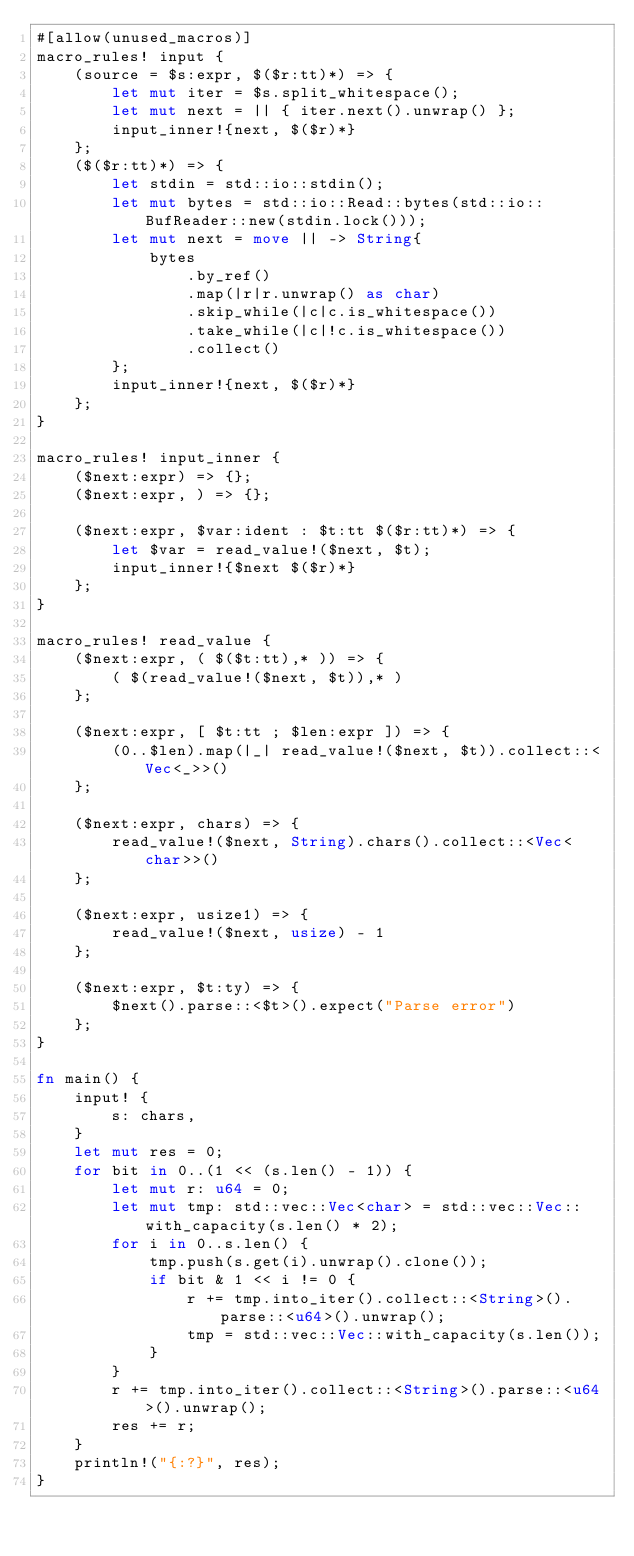<code> <loc_0><loc_0><loc_500><loc_500><_Rust_>#[allow(unused_macros)]
macro_rules! input {
    (source = $s:expr, $($r:tt)*) => {
        let mut iter = $s.split_whitespace();
        let mut next = || { iter.next().unwrap() };
        input_inner!{next, $($r)*}
    };
    ($($r:tt)*) => {
        let stdin = std::io::stdin();
        let mut bytes = std::io::Read::bytes(std::io::BufReader::new(stdin.lock()));
        let mut next = move || -> String{
            bytes
                .by_ref()
                .map(|r|r.unwrap() as char)
                .skip_while(|c|c.is_whitespace())
                .take_while(|c|!c.is_whitespace())
                .collect()
        };
        input_inner!{next, $($r)*}
    };
}

macro_rules! input_inner {
    ($next:expr) => {};
    ($next:expr, ) => {};

    ($next:expr, $var:ident : $t:tt $($r:tt)*) => {
        let $var = read_value!($next, $t);
        input_inner!{$next $($r)*}
    };
}

macro_rules! read_value {
    ($next:expr, ( $($t:tt),* )) => {
        ( $(read_value!($next, $t)),* )
    };

    ($next:expr, [ $t:tt ; $len:expr ]) => {
        (0..$len).map(|_| read_value!($next, $t)).collect::<Vec<_>>()
    };

    ($next:expr, chars) => {
        read_value!($next, String).chars().collect::<Vec<char>>()
    };

    ($next:expr, usize1) => {
        read_value!($next, usize) - 1
    };

    ($next:expr, $t:ty) => {
        $next().parse::<$t>().expect("Parse error")
    };
}

fn main() {
    input! {
        s: chars,
    }
    let mut res = 0;
    for bit in 0..(1 << (s.len() - 1)) {
        let mut r: u64 = 0;
        let mut tmp: std::vec::Vec<char> = std::vec::Vec::with_capacity(s.len() * 2);
        for i in 0..s.len() {
            tmp.push(s.get(i).unwrap().clone());
            if bit & 1 << i != 0 {
                r += tmp.into_iter().collect::<String>().parse::<u64>().unwrap();
                tmp = std::vec::Vec::with_capacity(s.len());
            }
        }
        r += tmp.into_iter().collect::<String>().parse::<u64>().unwrap();
        res += r;
    }
    println!("{:?}", res);
}</code> 